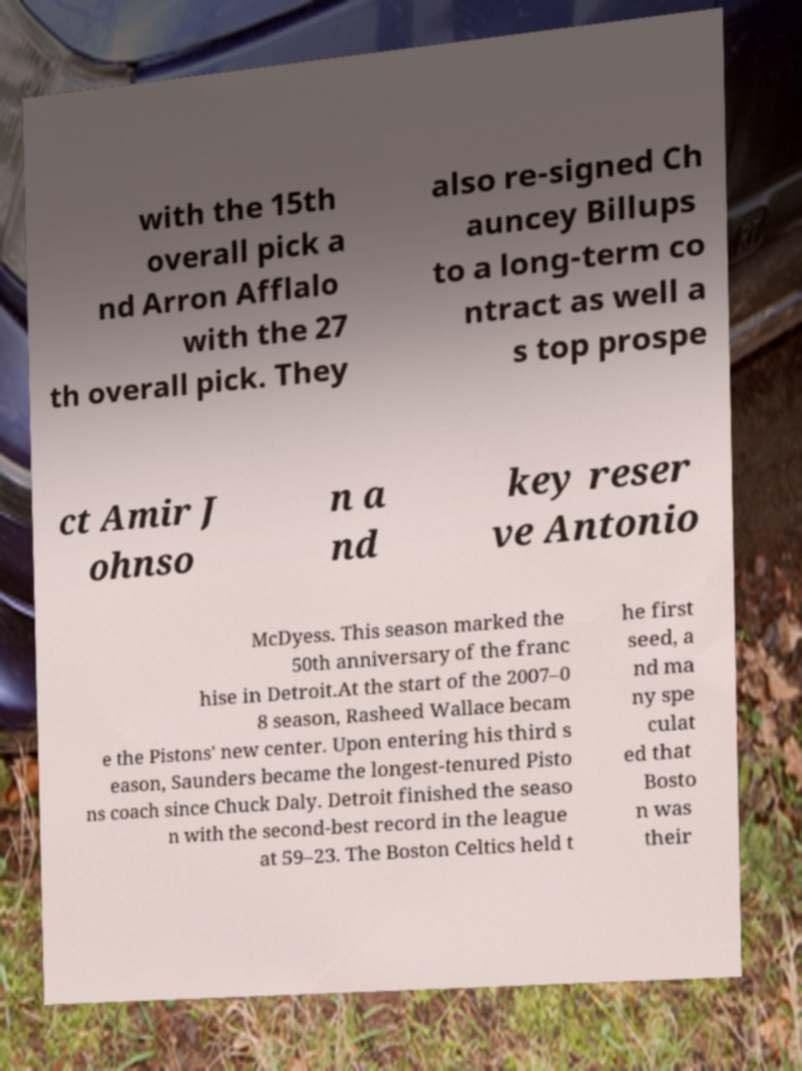For documentation purposes, I need the text within this image transcribed. Could you provide that? with the 15th overall pick a nd Arron Afflalo with the 27 th overall pick. They also re-signed Ch auncey Billups to a long-term co ntract as well a s top prospe ct Amir J ohnso n a nd key reser ve Antonio McDyess. This season marked the 50th anniversary of the franc hise in Detroit.At the start of the 2007–0 8 season, Rasheed Wallace becam e the Pistons' new center. Upon entering his third s eason, Saunders became the longest-tenured Pisto ns coach since Chuck Daly. Detroit finished the seaso n with the second-best record in the league at 59–23. The Boston Celtics held t he first seed, a nd ma ny spe culat ed that Bosto n was their 